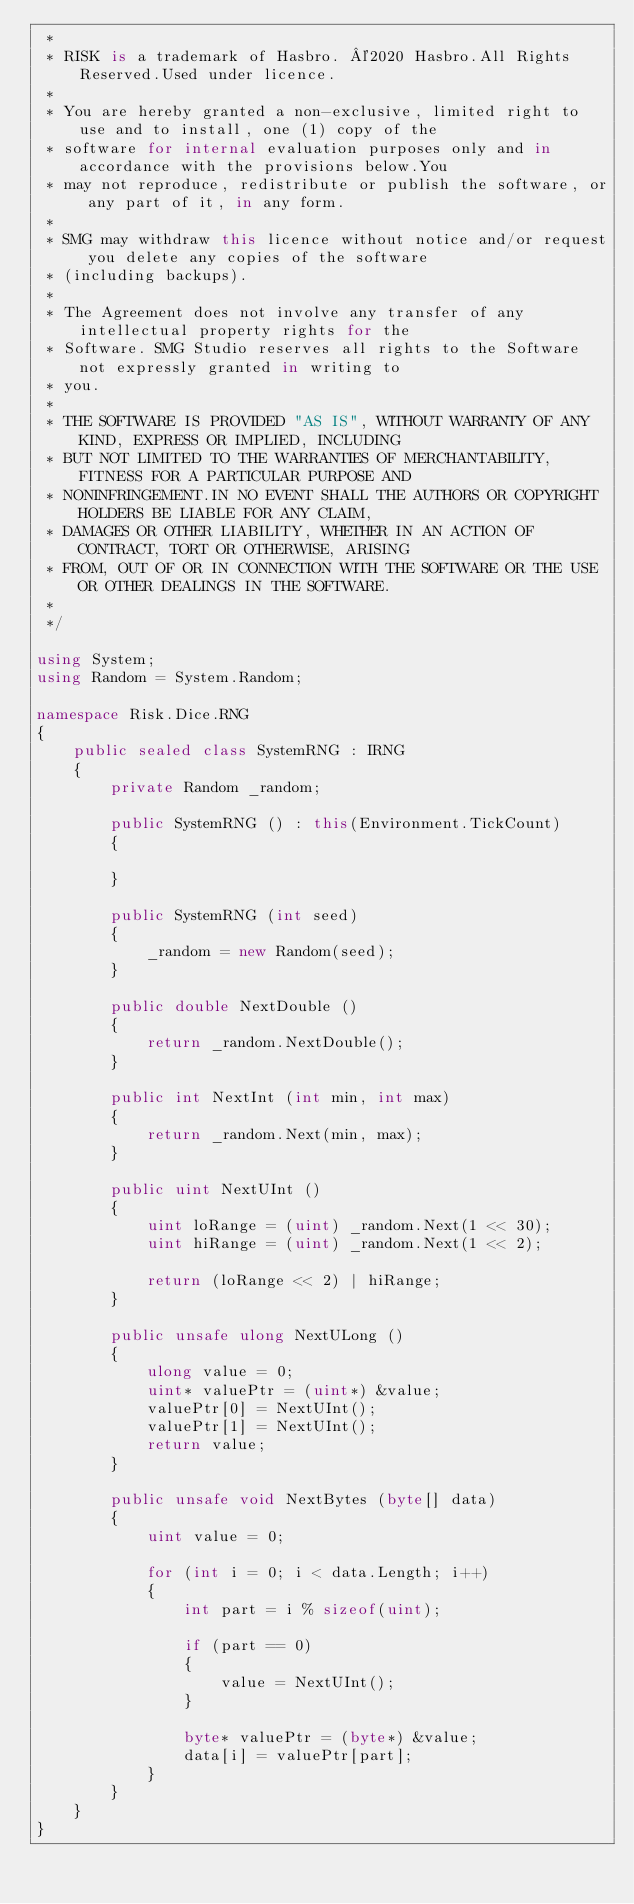Convert code to text. <code><loc_0><loc_0><loc_500><loc_500><_C#_> *
 * RISK is a trademark of Hasbro. ©2020 Hasbro.All Rights Reserved.Used under licence.
 *
 * You are hereby granted a non-exclusive, limited right to use and to install, one (1) copy of the
 * software for internal evaluation purposes only and in accordance with the provisions below.You
 * may not reproduce, redistribute or publish the software, or any part of it, in any form.
 * 
 * SMG may withdraw this licence without notice and/or request you delete any copies of the software
 * (including backups).
 *
 * The Agreement does not involve any transfer of any intellectual property rights for the
 * Software. SMG Studio reserves all rights to the Software not expressly granted in writing to
 * you.
 *
 * THE SOFTWARE IS PROVIDED "AS IS", WITHOUT WARRANTY OF ANY KIND, EXPRESS OR IMPLIED, INCLUDING
 * BUT NOT LIMITED TO THE WARRANTIES OF MERCHANTABILITY, FITNESS FOR A PARTICULAR PURPOSE AND
 * NONINFRINGEMENT.IN NO EVENT SHALL THE AUTHORS OR COPYRIGHT HOLDERS BE LIABLE FOR ANY CLAIM,
 * DAMAGES OR OTHER LIABILITY, WHETHER IN AN ACTION OF CONTRACT, TORT OR OTHERWISE, ARISING
 * FROM, OUT OF OR IN CONNECTION WITH THE SOFTWARE OR THE USE OR OTHER DEALINGS IN THE SOFTWARE.
 *
 */

using System;
using Random = System.Random;

namespace Risk.Dice.RNG
{
    public sealed class SystemRNG : IRNG
    {
        private Random _random;

        public SystemRNG () : this(Environment.TickCount)
        {
            
        }

        public SystemRNG (int seed)
        {
            _random = new Random(seed);
        }

        public double NextDouble ()
        {
            return _random.NextDouble();
        }

        public int NextInt (int min, int max)
        {
            return _random.Next(min, max);
        }

        public uint NextUInt ()
        {
            uint loRange = (uint) _random.Next(1 << 30);
            uint hiRange = (uint) _random.Next(1 << 2);

            return (loRange << 2) | hiRange;
        }

        public unsafe ulong NextULong ()
        {
            ulong value = 0;
            uint* valuePtr = (uint*) &value;
            valuePtr[0] = NextUInt();
            valuePtr[1] = NextUInt();
            return value;
        }

        public unsafe void NextBytes (byte[] data)
        {
            uint value = 0;

            for (int i = 0; i < data.Length; i++)
            {
                int part = i % sizeof(uint);

                if (part == 0)
                {
                    value = NextUInt();
                }

                byte* valuePtr = (byte*) &value;
                data[i] = valuePtr[part];
            }
        }
    }
}</code> 